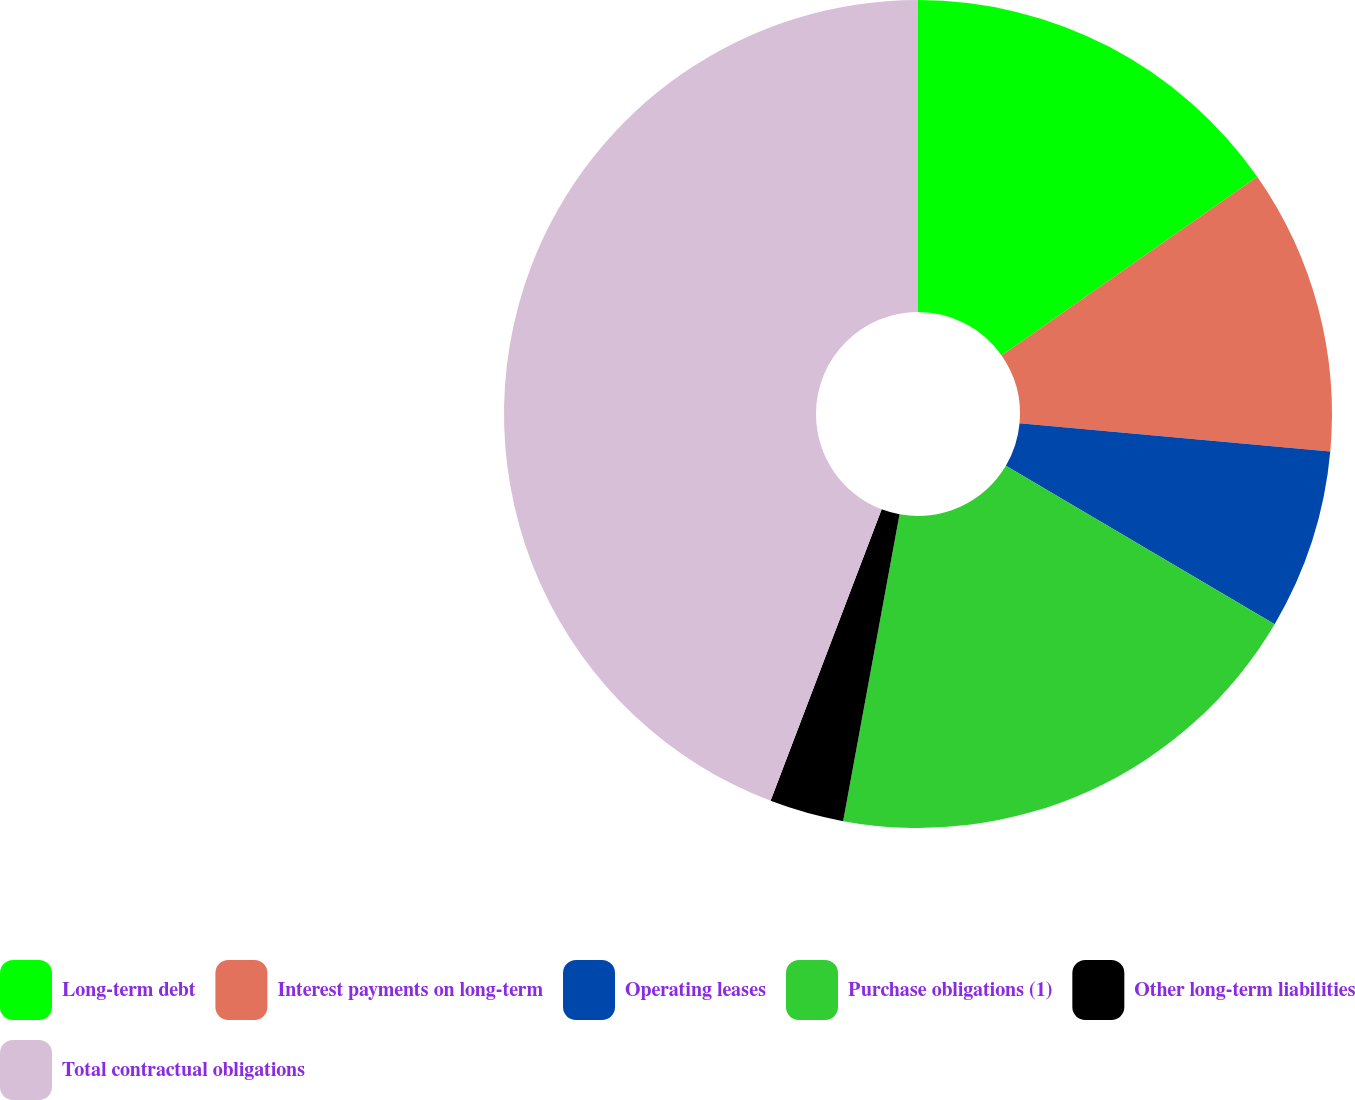<chart> <loc_0><loc_0><loc_500><loc_500><pie_chart><fcel>Long-term debt<fcel>Interest payments on long-term<fcel>Operating leases<fcel>Purchase obligations (1)<fcel>Other long-term liabilities<fcel>Total contractual obligations<nl><fcel>15.29%<fcel>11.16%<fcel>7.03%<fcel>19.42%<fcel>2.9%<fcel>44.21%<nl></chart> 